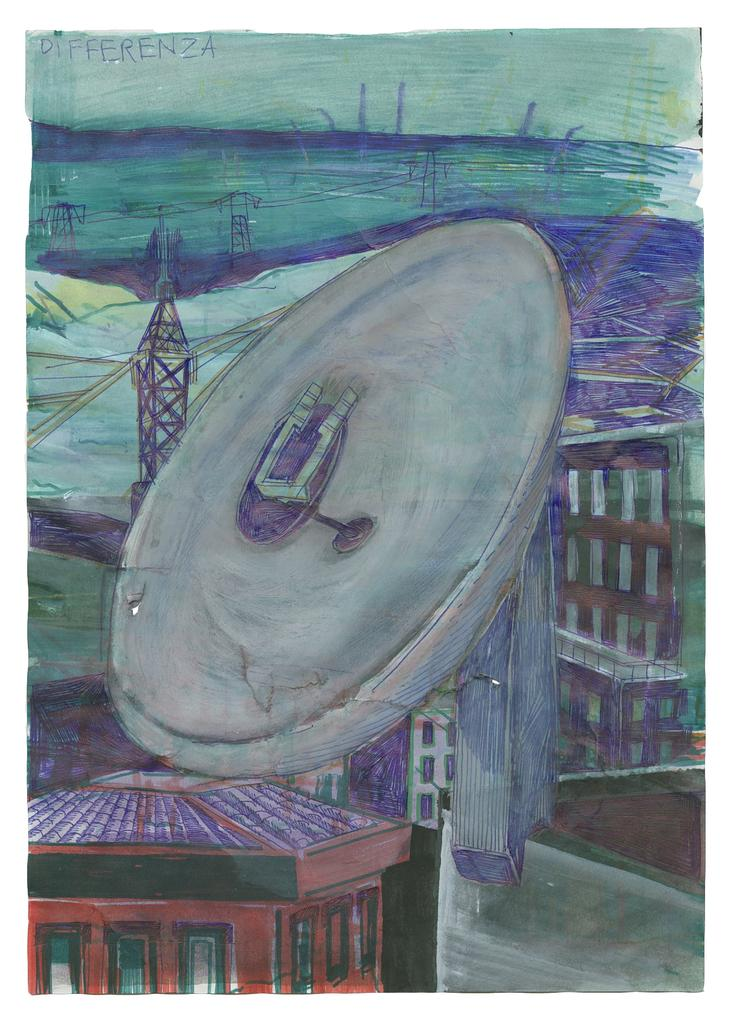What is the main subject of the image? The image contains a painting. What is being depicted in the painting? The painting depicts buildings and towers. Are there any other objects or elements in the painting? Yes, the painting includes other objects. What is the rate at which the ink is being used in the painting? There is no mention of ink being used in the painting, as it is a visual art piece and not a written or printed work. 